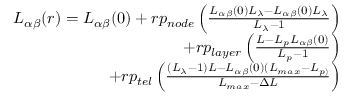<formula> <loc_0><loc_0><loc_500><loc_500>\begin{array} { r } { L _ { \alpha \beta } ( r ) = L _ { \alpha \beta } ( 0 ) + r p _ { n o d e } \left ( \frac { L _ { \alpha \beta } ( 0 ) L _ { \lambda } - L _ { \alpha \beta } ( 0 ) L _ { \lambda } } { L _ { \lambda } - 1 } \right ) } \\ { + r p _ { l a y e r } \left ( \frac { L - L _ { p } L _ { \alpha \beta } ( 0 ) } { L _ { p } - 1 } \right ) } \\ { + r p _ { t e l } \left ( \frac { ( L _ { \lambda } - 1 ) L - L _ { \alpha \beta } ( 0 ) ( L _ { \max } - L _ { p ) } } { L _ { \max } - \Delta L } \right ) } \end{array}</formula> 